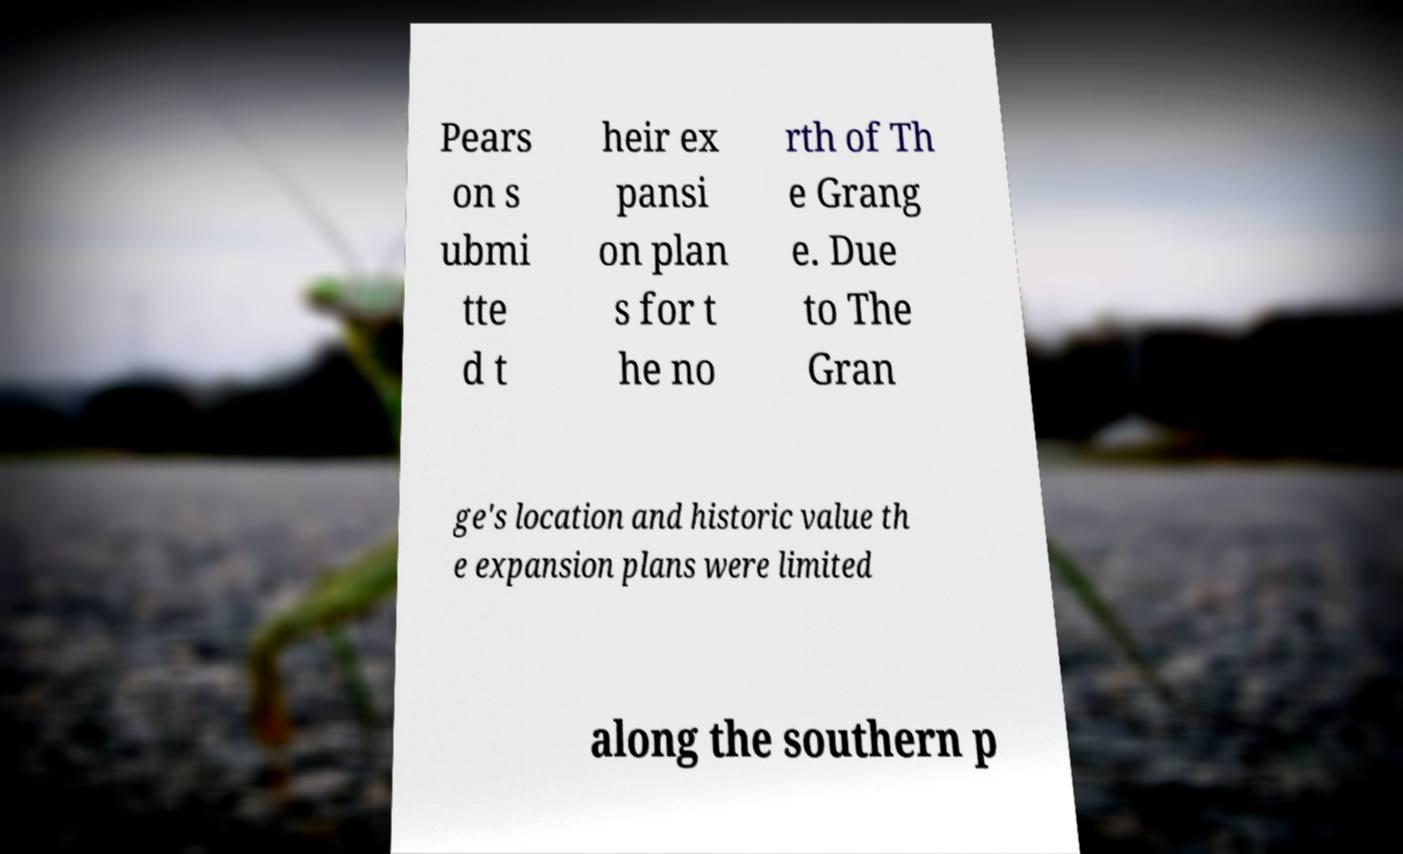What messages or text are displayed in this image? I need them in a readable, typed format. Pears on s ubmi tte d t heir ex pansi on plan s for t he no rth of Th e Grang e. Due to The Gran ge's location and historic value th e expansion plans were limited along the southern p 